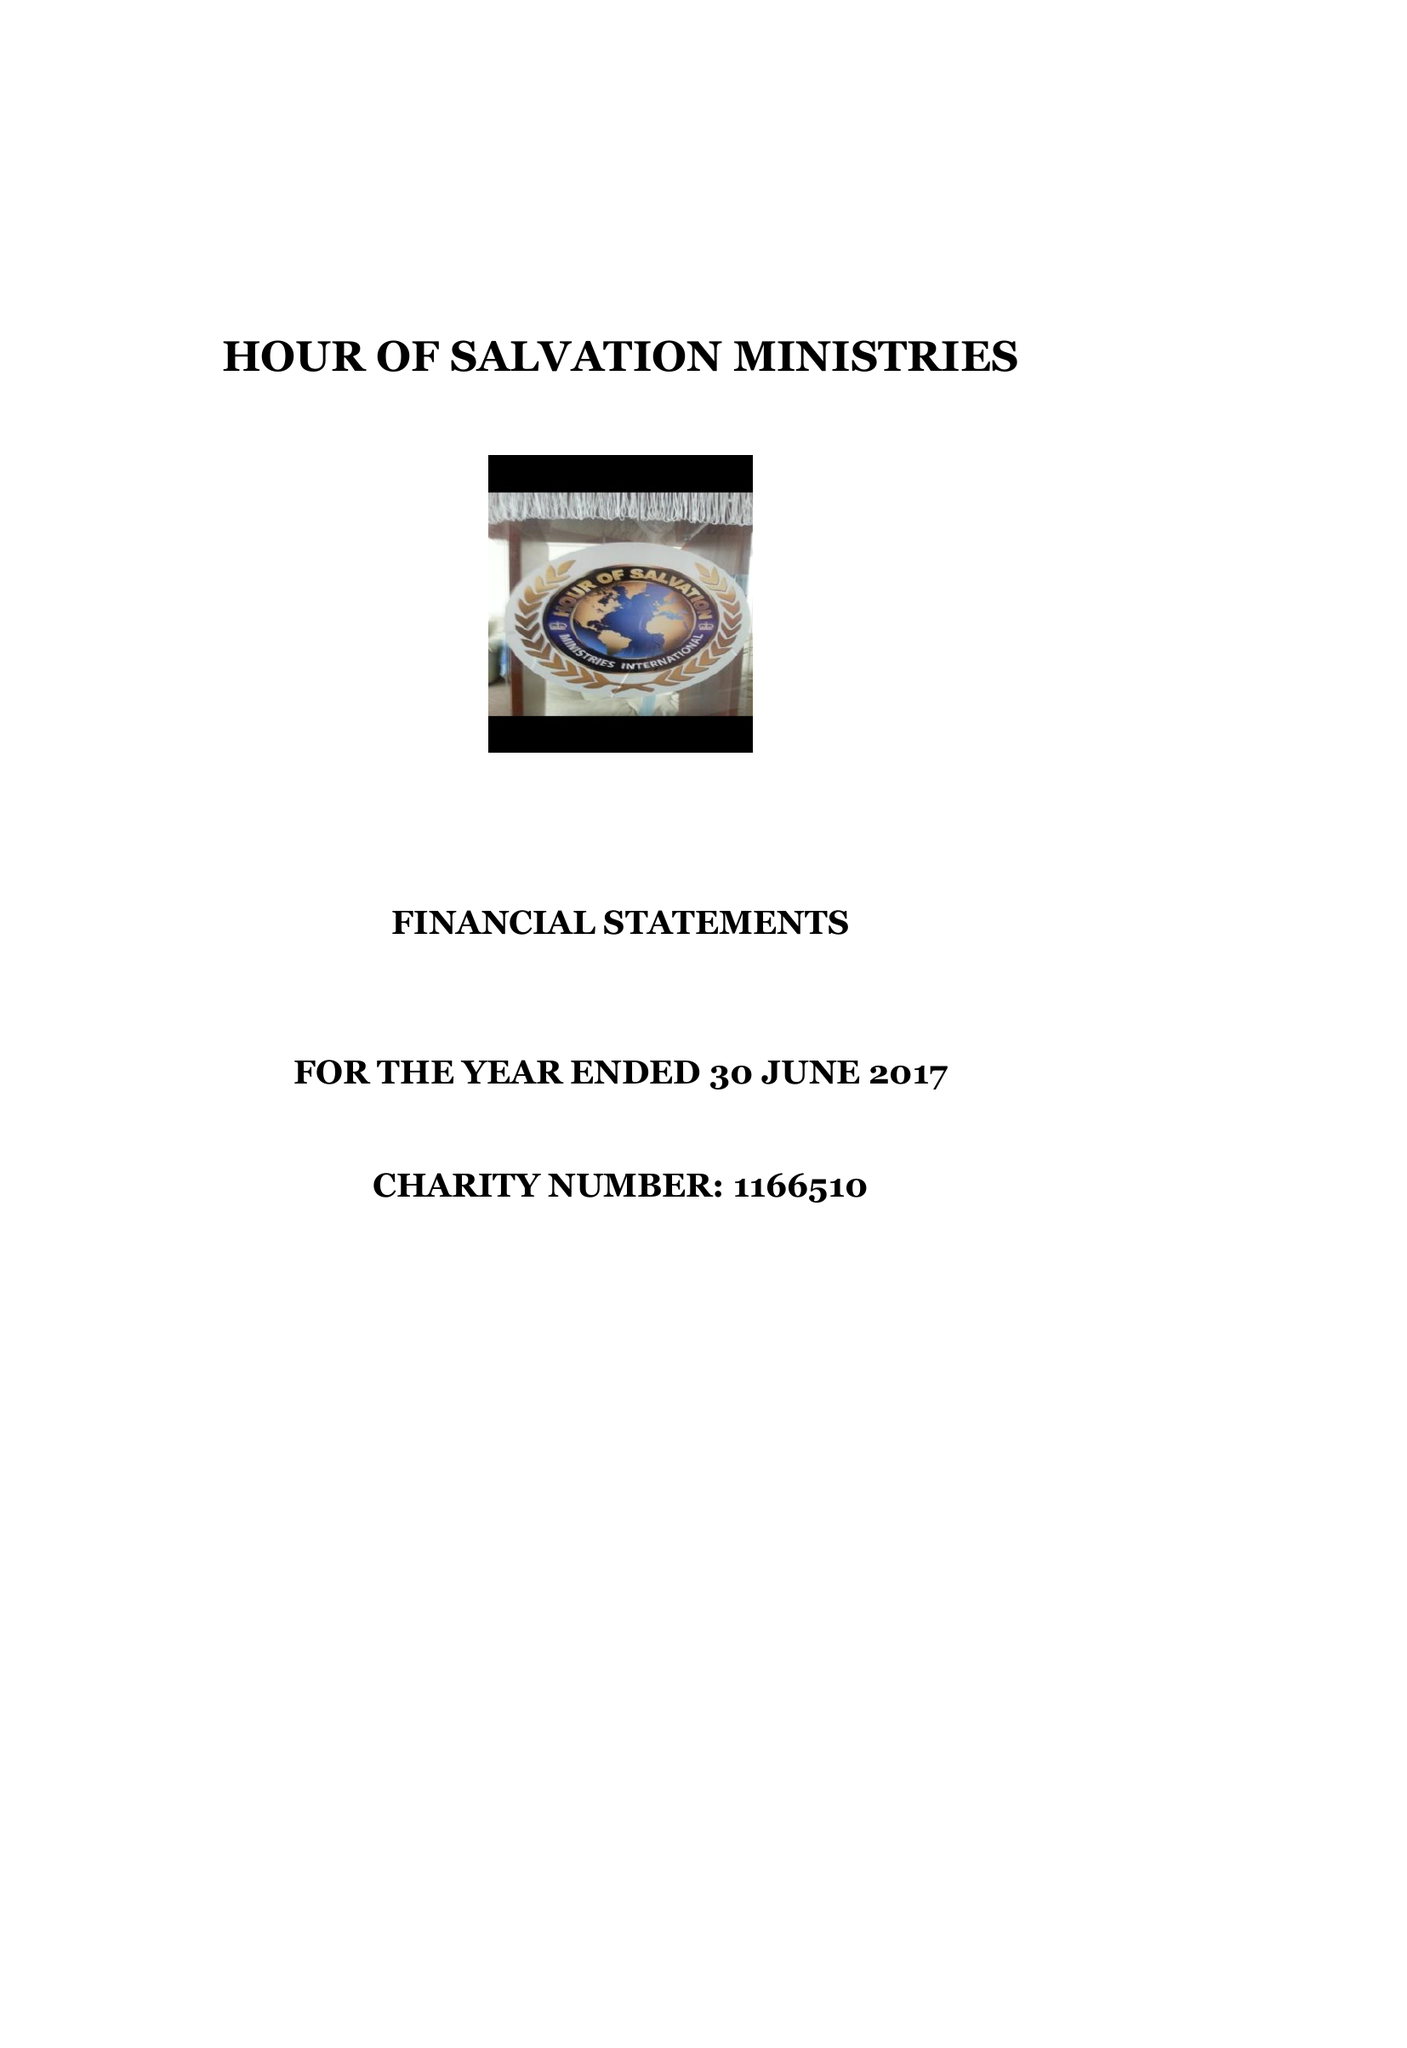What is the value for the report_date?
Answer the question using a single word or phrase. 2017-06-30 